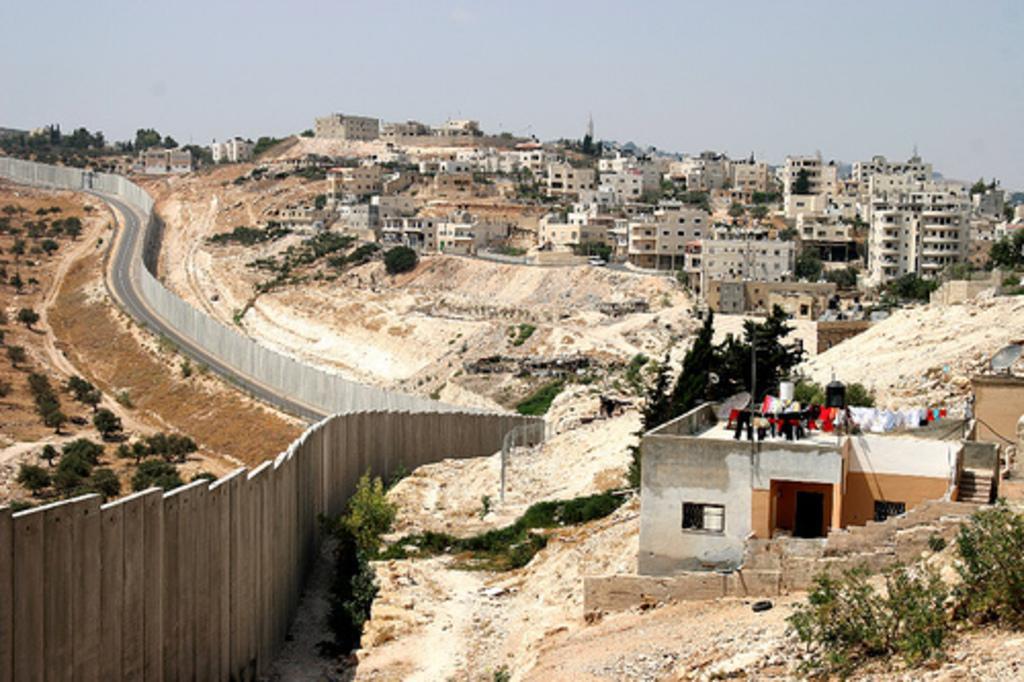Could you give a brief overview of what you see in this image? This picture might be taken from outside of the building. In this image, on the right side, we can see a house, windows and some clothes, we can also see a staircase on the house. On the right side, we can also see some buildings, windows, trees. On the left side, we can also see some trees and a wood wall. In the background, we can see some trees. On the top, we can see a sky, at the bottom there is a land with some stones. 